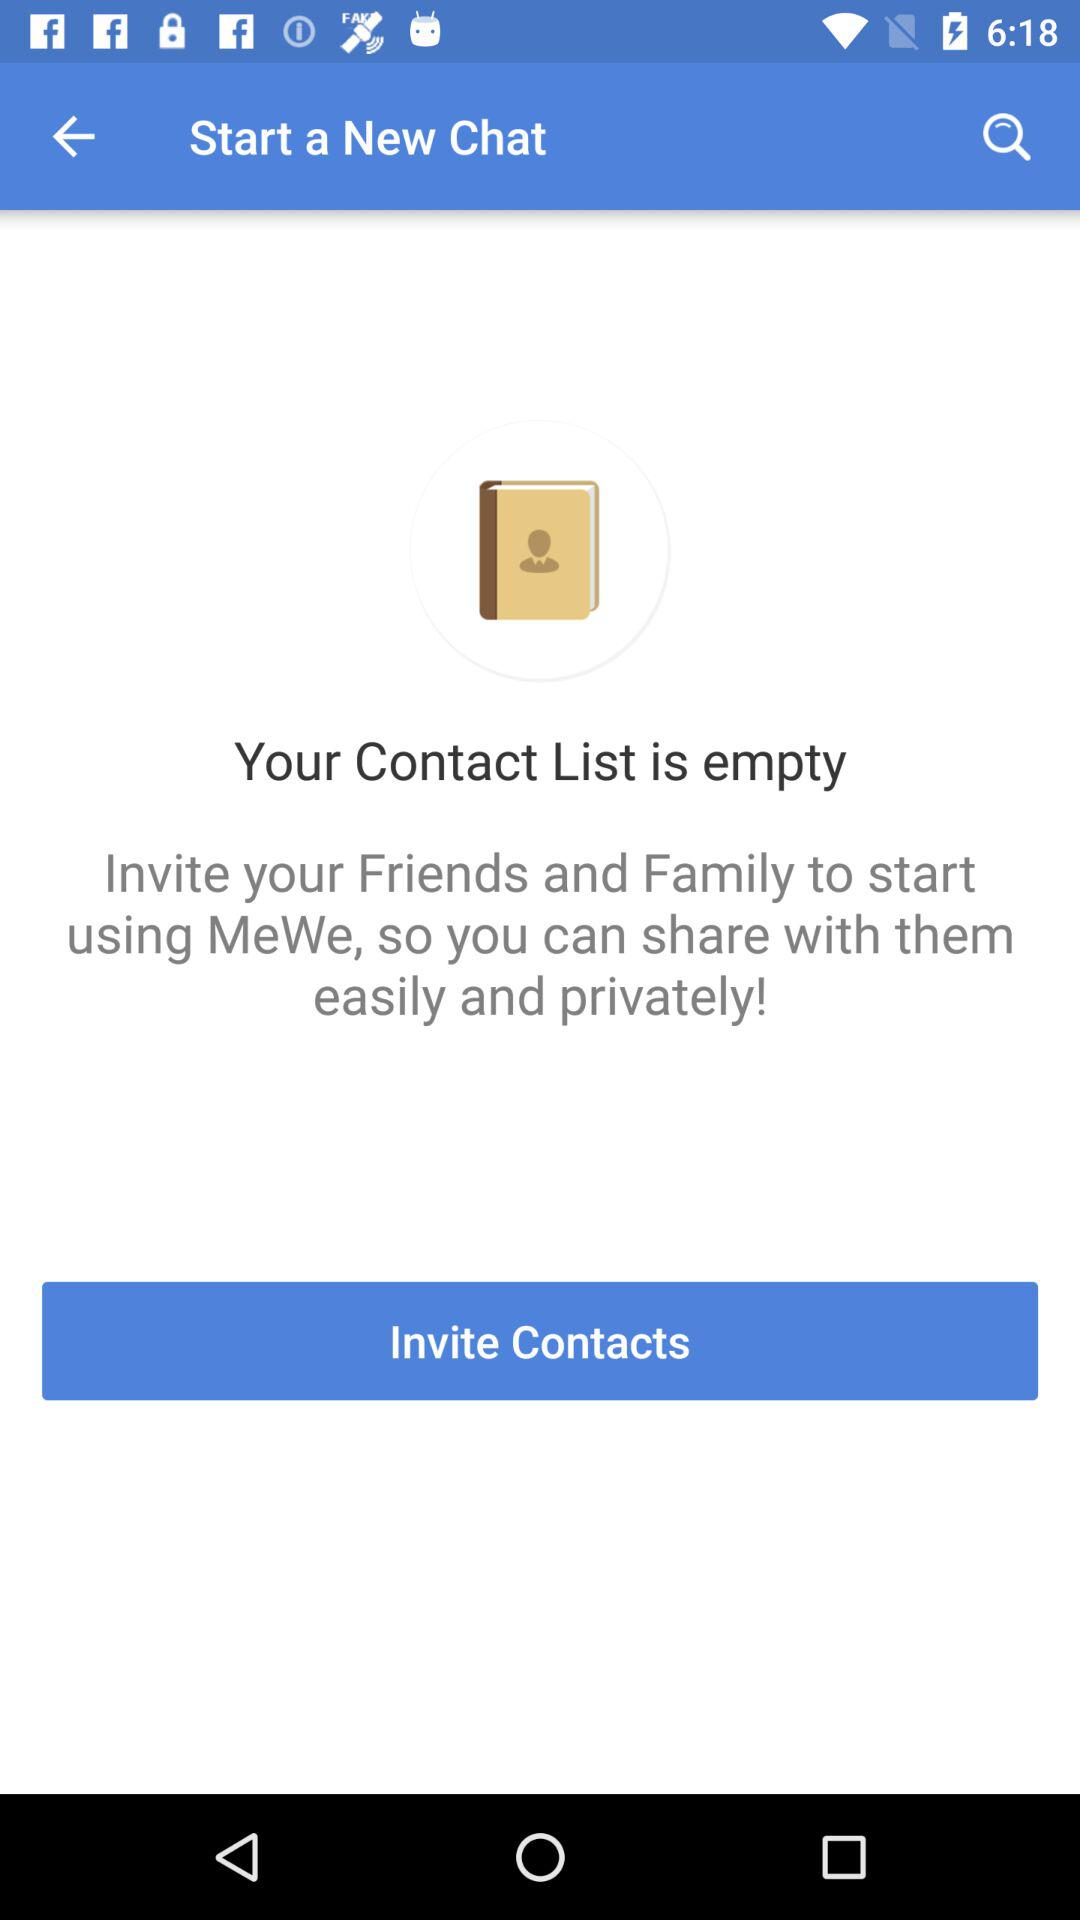Is there anyone in the contact list? The contact list is empty. 